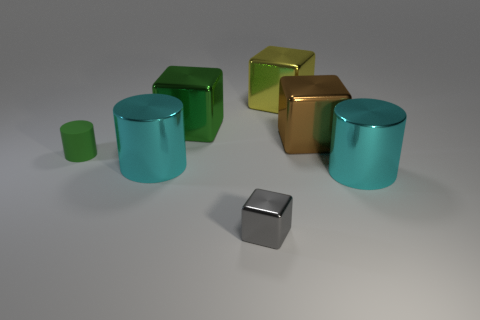Is there any significance to the colors chosen for the objects? Color choice can be subjective, but these particular shades of green, gold, and blue might suggest a theme or mood, such as tranquility and luxury, or could be chosen to contrast well with one another. 